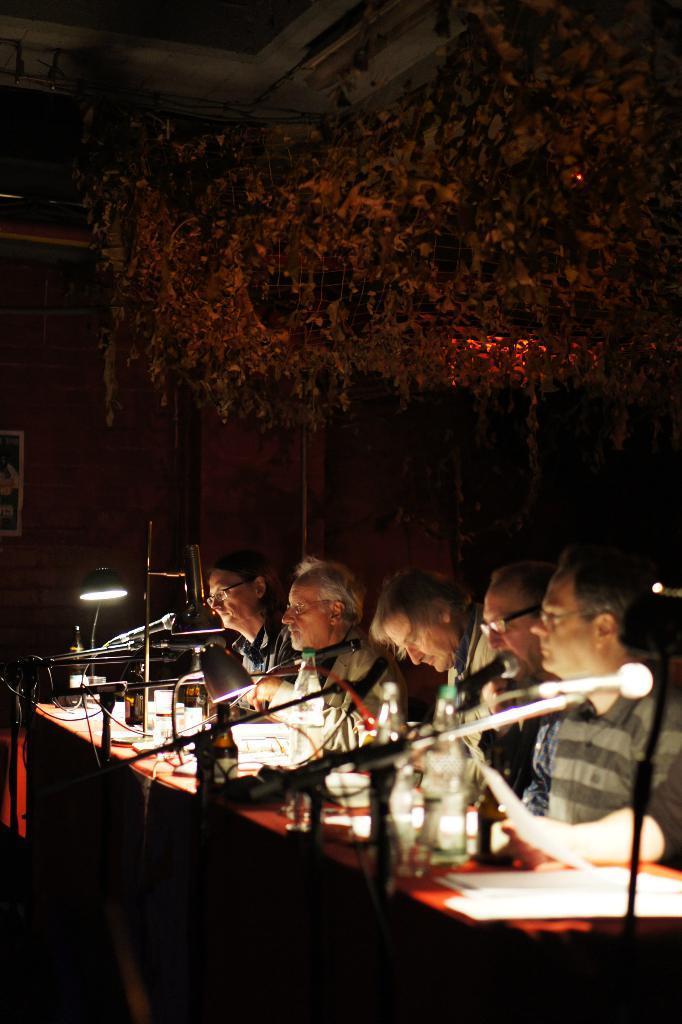In one or two sentences, can you explain what this image depicts? In this image there are people sitting. Before them there is a table having few bottles and mike's. There is a lamp on the table having few objects. Top of the image decorative items are hanging from the roof. Left side a frame is attached to the wall. 